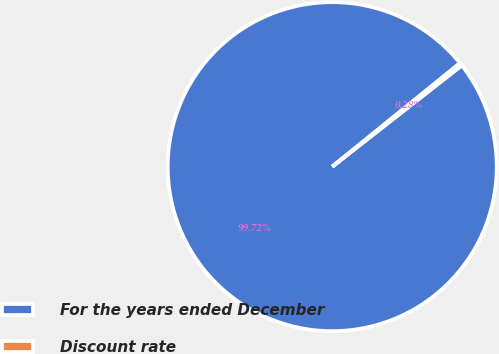<chart> <loc_0><loc_0><loc_500><loc_500><pie_chart><fcel>For the years ended December<fcel>Discount rate<nl><fcel>99.72%<fcel>0.28%<nl></chart> 